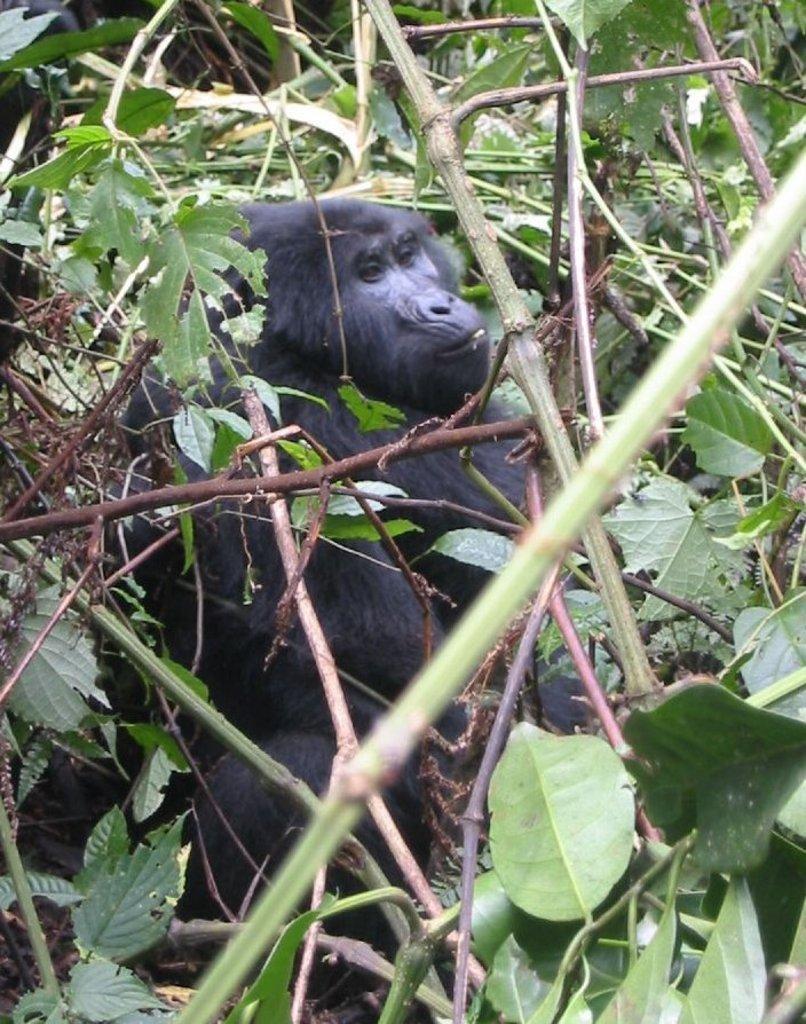Please provide a concise description of this image. In this image, I can see a gorilla. These are the trees and plants with leaves and branches. 